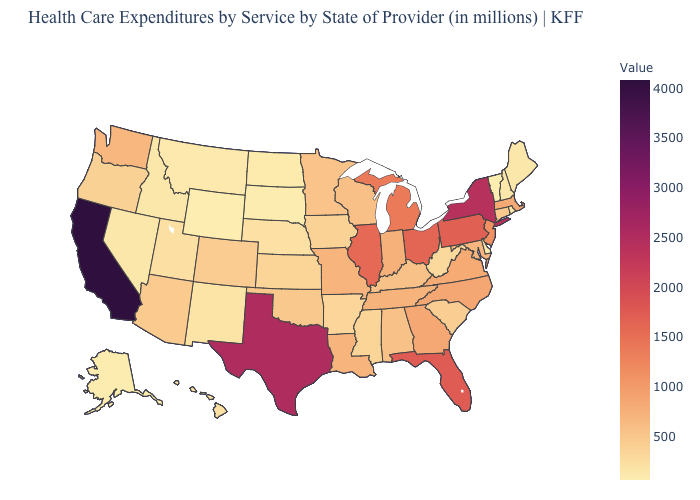Does New Mexico have the highest value in the USA?
Concise answer only. No. Does Vermont have the lowest value in the USA?
Be succinct. Yes. Among the states that border Georgia , does South Carolina have the lowest value?
Give a very brief answer. Yes. Does the map have missing data?
Short answer required. No. Among the states that border New York , which have the lowest value?
Quick response, please. Vermont. Does Ohio have a higher value than Texas?
Quick response, please. No. 